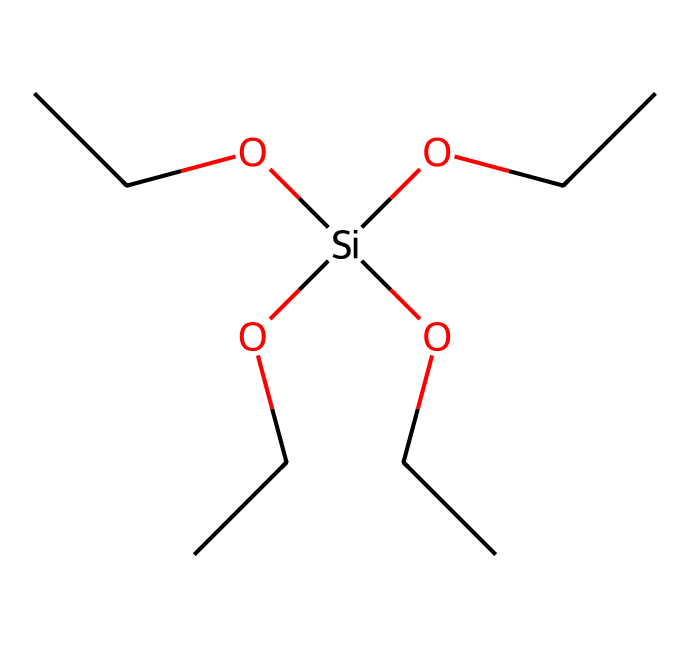What is the molecular formula of tetraethoxysilane? To determine the molecular formula, we can analyze the given SMILES representation. The compound consists of silicon (Si), oxygen (O), and carbon (C) atoms. Counting each atom from the structure, we find 4 ethoxy groups (C2H5O) attached to one Si atom, leading to 4 carbon atoms, 10 hydrogen atoms, and 4 oxygen atoms from these groups, plus 1 silicon atom. Thus, the full molecular formula is SiC8H20O4.
Answer: SiC8H20O4 How many oxygen atoms are present in this compound? By examining the SMILES representation, we can see that there are four ethoxy groups, and each ethoxy group contains one oxygen atom. Therefore, the total number of oxygen atoms present in the compound is four.
Answer: 4 What type of chemical is tetraethoxysilane classified as? Tetraethoxysilane is classified as a silane, which is a type of organosilicon compound. This classification is evident from the presence of the silicon atom bonded to alkyl (ethoxy) groups in the structure.
Answer: silane What is the significance of the ethoxy groups in this silane? Ethoxy groups in tetraethoxysilane play a crucial role as they provide reactivity for the silicon atom. When this compound is used in conservation, these ethoxy groups can interact with moisture and hydroxyl groups in the substrate, promoting bonding and adhesion.
Answer: provide reactivity How many carbon atoms are in each ethoxy group? Each ethoxy group contains two carbon atoms, as each is represented by C2 in the structural breakdown of the molecular formula from the SMILES notation. This counting is consistent throughout the four ethoxy groups attached to the silicon.
Answer: 2 What would happen to this compound if it were to hydrolyze? Upon hydrolysis, tetraethoxysilane would react with water, resulting in the formation of silanol groups and the release of ethanol. This reaction is significant in applications such as surface modification and bonding in conservation efforts.
Answer: form silanol groups 